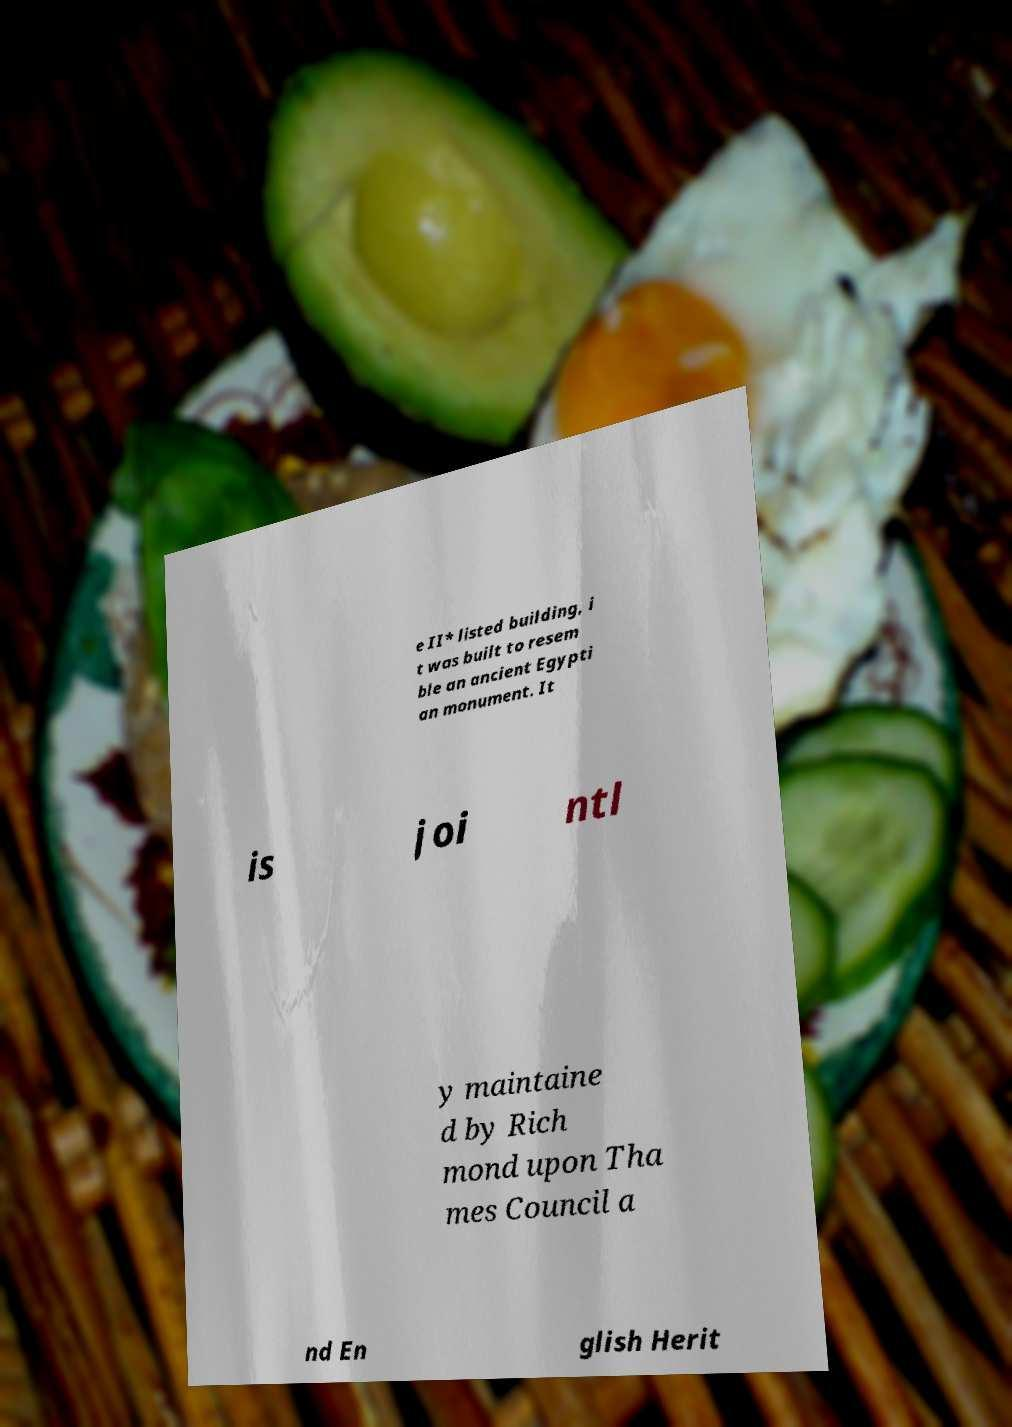Please identify and transcribe the text found in this image. e II* listed building, i t was built to resem ble an ancient Egypti an monument. It is joi ntl y maintaine d by Rich mond upon Tha mes Council a nd En glish Herit 